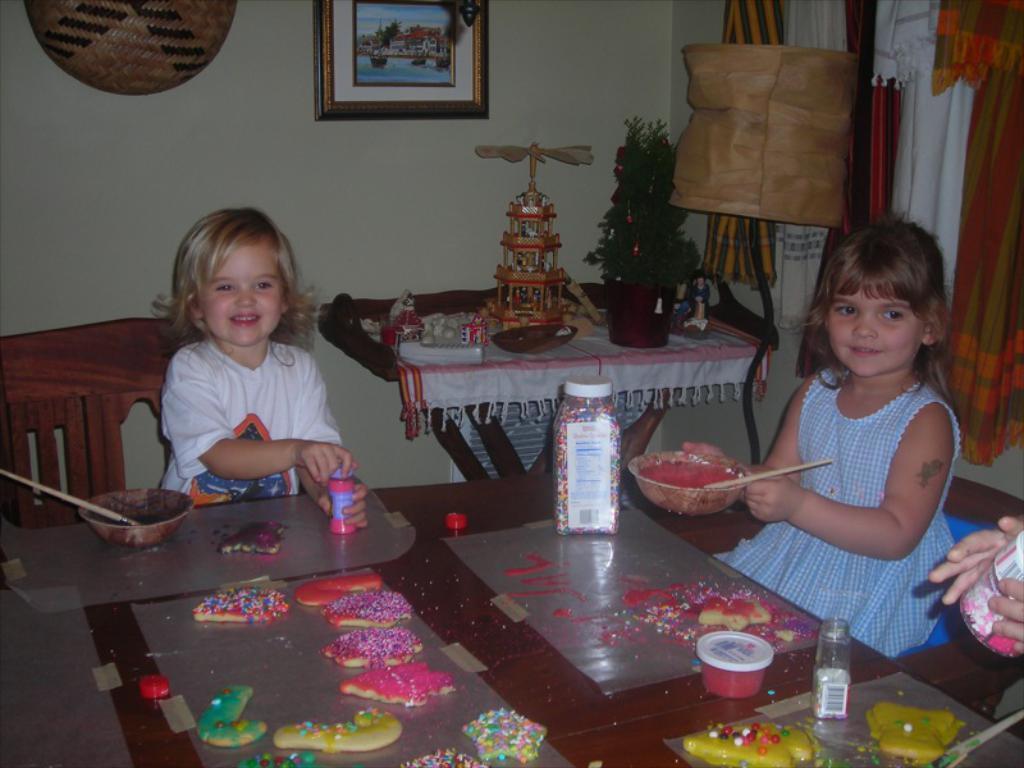Please provide a concise description of this image. In this image we can see two girls sitting on the chair, and in front here is the table and paints and some objects on it, and at back here is the table and x-mass tree and toys on it, and here is the wall and photo frame on it. 